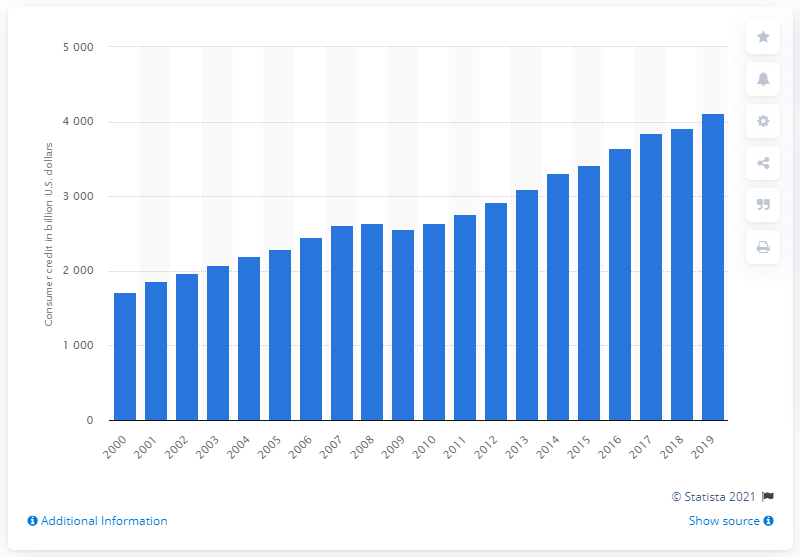Specify some key components in this picture. The total amount of consumer credit outstanding in the United States in 2019 was approximately $4110.43 billion. 